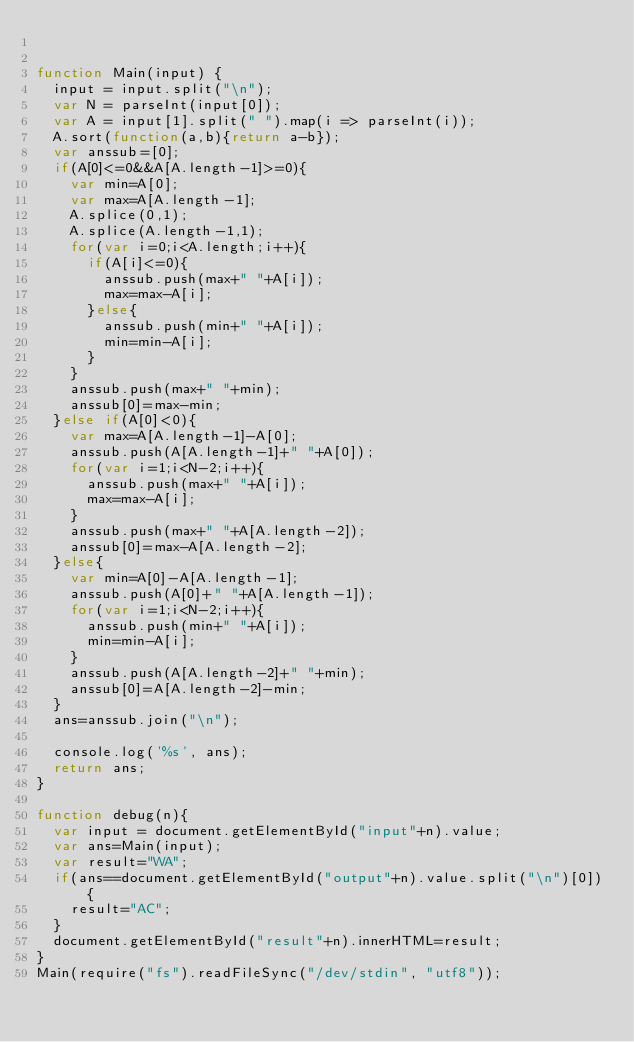<code> <loc_0><loc_0><loc_500><loc_500><_JavaScript_>

function Main(input) {
  input = input.split("\n");
  var N = parseInt(input[0]);
  var A = input[1].split(" ").map(i => parseInt(i));
  A.sort(function(a,b){return a-b});
  var anssub=[0];
  if(A[0]<=0&&A[A.length-1]>=0){
    var min=A[0];
    var max=A[A.length-1];
    A.splice(0,1);
    A.splice(A.length-1,1);
    for(var i=0;i<A.length;i++){
      if(A[i]<=0){
        anssub.push(max+" "+A[i]);
        max=max-A[i];
      }else{
        anssub.push(min+" "+A[i]);
        min=min-A[i];
      }
    }
    anssub.push(max+" "+min);
    anssub[0]=max-min;
  }else if(A[0]<0){
    var max=A[A.length-1]-A[0];
    anssub.push(A[A.length-1]+" "+A[0]);
    for(var i=1;i<N-2;i++){
      anssub.push(max+" "+A[i]);
      max=max-A[i];
    }
    anssub.push(max+" "+A[A.length-2]);
    anssub[0]=max-A[A.length-2];
  }else{
    var min=A[0]-A[A.length-1];
    anssub.push(A[0]+" "+A[A.length-1]);
    for(var i=1;i<N-2;i++){
      anssub.push(min+" "+A[i]);
      min=min-A[i];
    }
    anssub.push(A[A.length-2]+" "+min);
    anssub[0]=A[A.length-2]-min;
  }
  ans=anssub.join("\n");

  console.log('%s', ans);
  return ans;
}

function debug(n){
  var input = document.getElementById("input"+n).value;
  var ans=Main(input);
  var result="WA";
  if(ans==document.getElementById("output"+n).value.split("\n")[0]){
    result="AC";
  }
  document.getElementById("result"+n).innerHTML=result;
}
Main(require("fs").readFileSync("/dev/stdin", "utf8"));</code> 